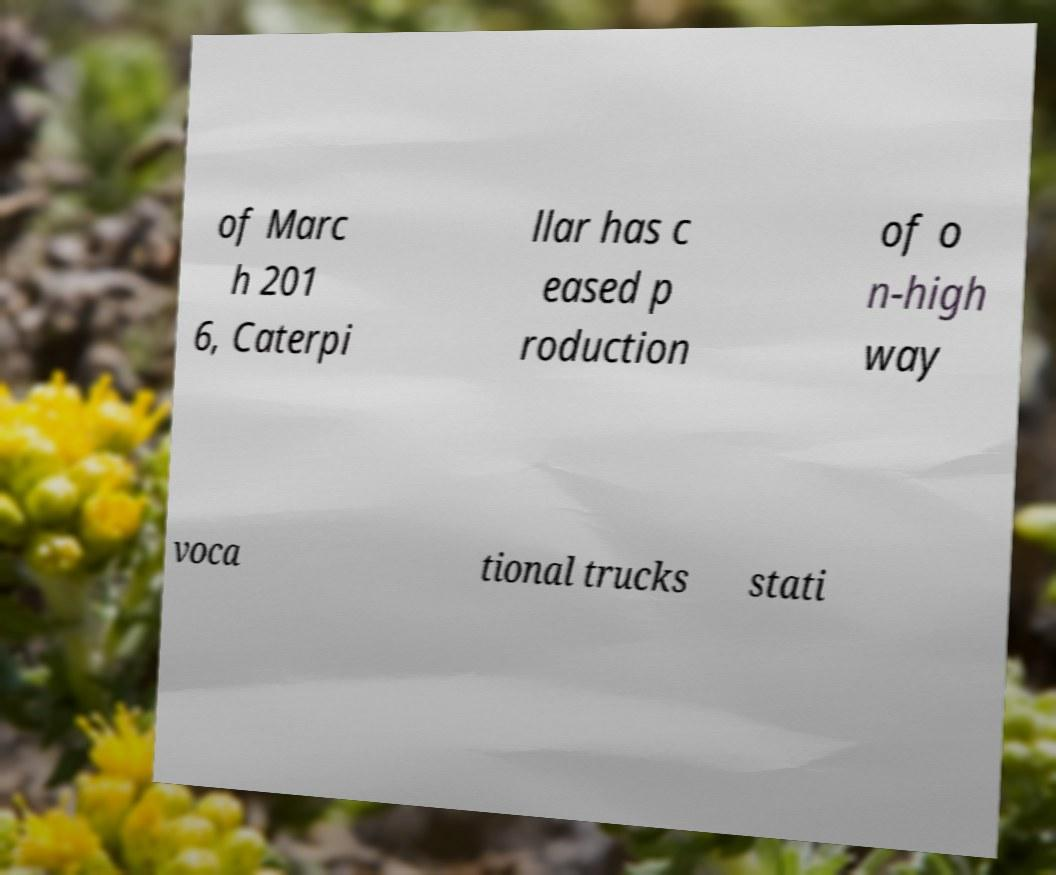Please identify and transcribe the text found in this image. of Marc h 201 6, Caterpi llar has c eased p roduction of o n-high way voca tional trucks stati 